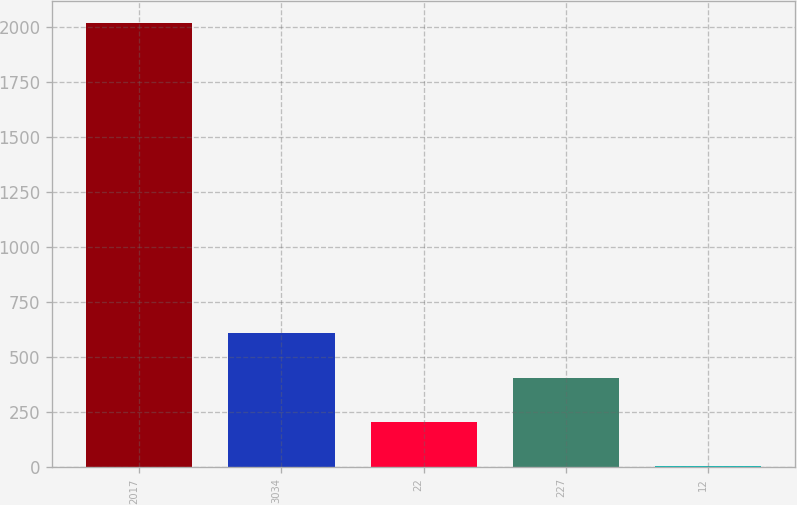<chart> <loc_0><loc_0><loc_500><loc_500><bar_chart><fcel>2017<fcel>3034<fcel>22<fcel>227<fcel>12<nl><fcel>2015<fcel>605.34<fcel>202.58<fcel>403.96<fcel>1.2<nl></chart> 